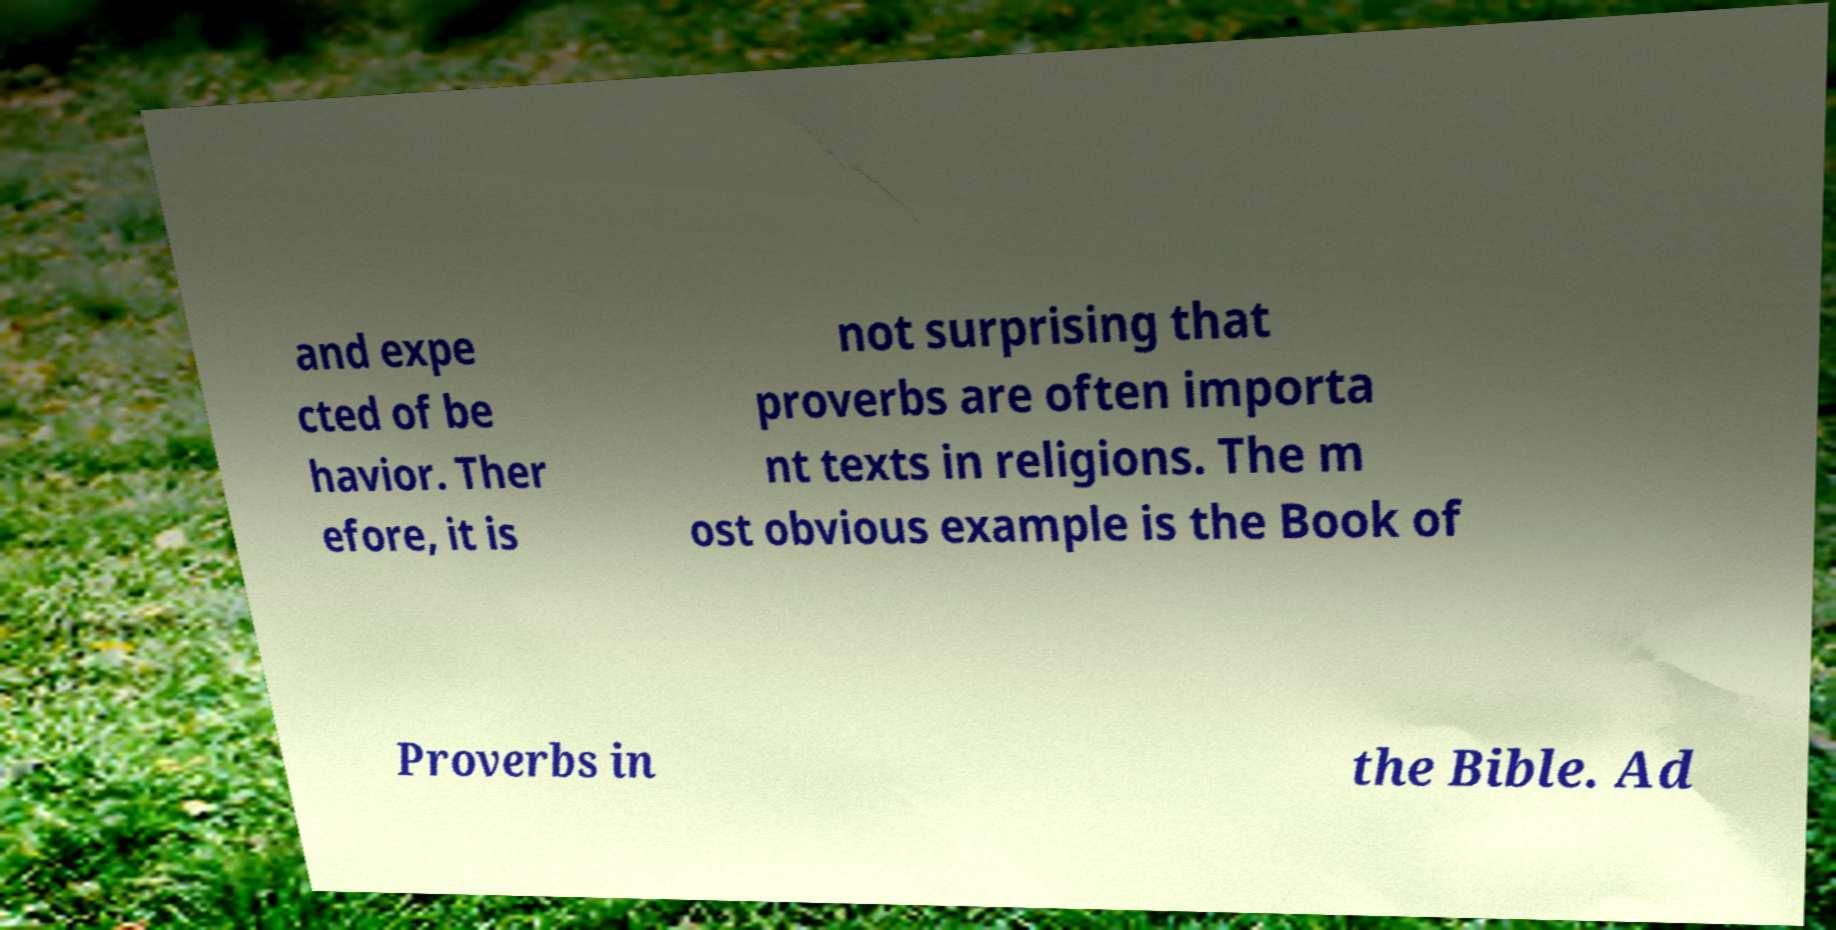I need the written content from this picture converted into text. Can you do that? and expe cted of be havior. Ther efore, it is not surprising that proverbs are often importa nt texts in religions. The m ost obvious example is the Book of Proverbs in the Bible. Ad 